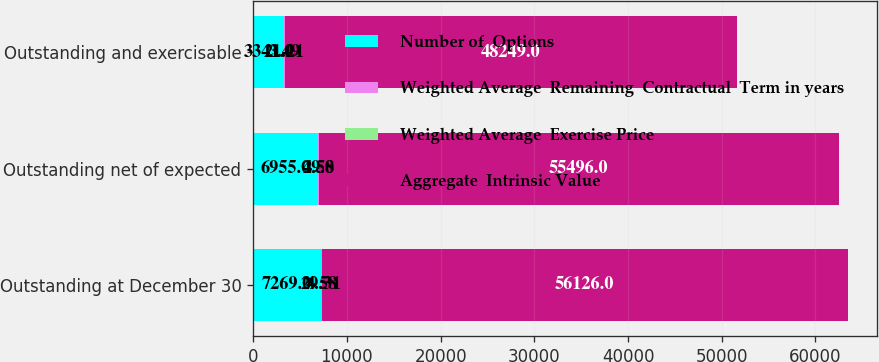Convert chart to OTSL. <chart><loc_0><loc_0><loc_500><loc_500><stacked_bar_chart><ecel><fcel>Outstanding at December 30<fcel>Outstanding net of expected<fcel>Outstanding and exercisable<nl><fcel>Number of  Options<fcel>7269<fcel>6955<fcel>3341<nl><fcel>Weighted Average  Remaining  Contractual  Term in years<fcel>29.31<fcel>29<fcel>21.21<nl><fcel>Weighted Average  Exercise Price<fcel>4.58<fcel>4.58<fcel>3.49<nl><fcel>Aggregate  Intrinsic Value<fcel>56126<fcel>55496<fcel>48249<nl></chart> 